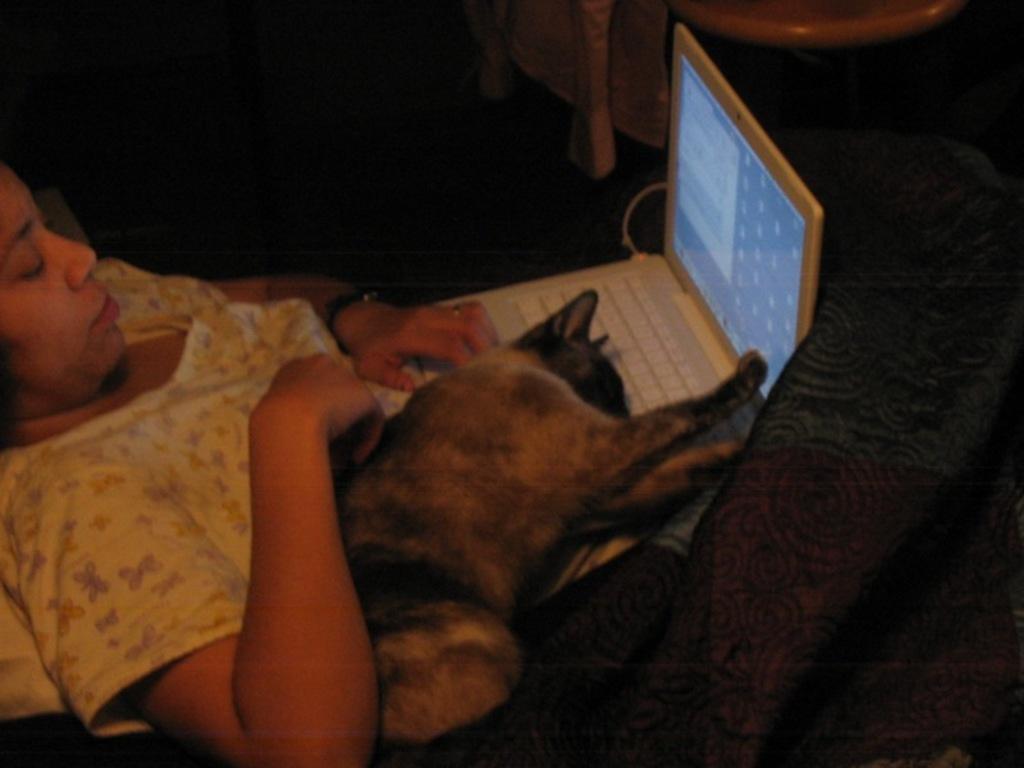Can you describe this image briefly? In this image we can see a person lying. There are laptop, cat and blanket on her. 